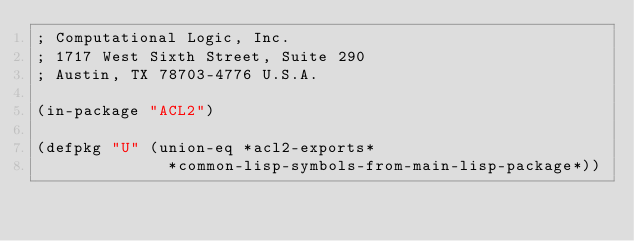<code> <loc_0><loc_0><loc_500><loc_500><_Lisp_>; Computational Logic, Inc.
; 1717 West Sixth Street, Suite 290
; Austin, TX 78703-4776 U.S.A.

(in-package "ACL2")

(defpkg "U" (union-eq *acl2-exports*
		      *common-lisp-symbols-from-main-lisp-package*))
</code> 